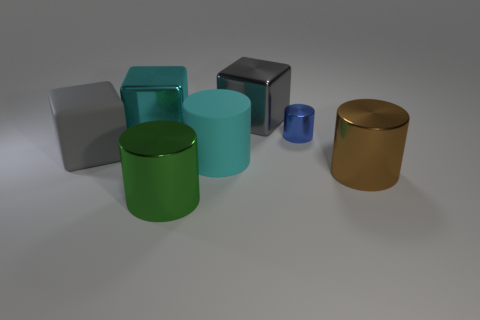Subtract all brown cylinders. How many gray blocks are left? 2 Subtract 2 cylinders. How many cylinders are left? 2 Subtract all blue cylinders. How many cylinders are left? 3 Subtract all blue cylinders. How many cylinders are left? 3 Subtract all gray cylinders. Subtract all gray blocks. How many cylinders are left? 4 Add 3 small yellow cylinders. How many objects exist? 10 Subtract all cylinders. How many objects are left? 3 Add 1 blue objects. How many blue objects are left? 2 Add 1 small things. How many small things exist? 2 Subtract 0 red cylinders. How many objects are left? 7 